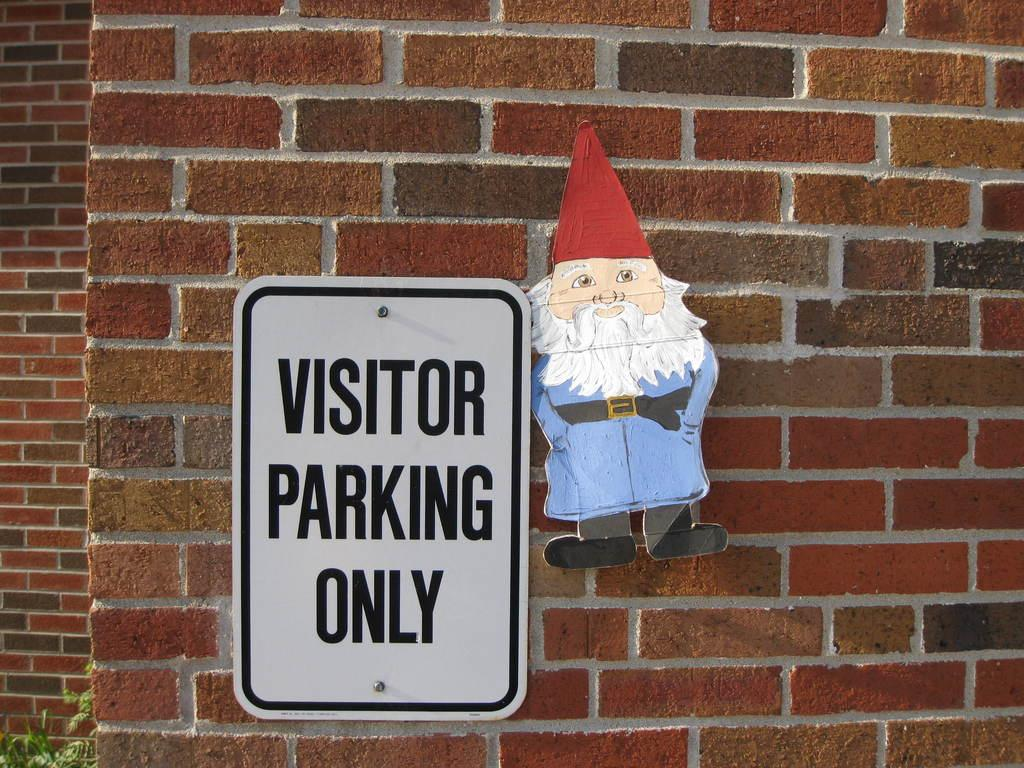What is the main structure visible in the image? There is a wall in the image. What is attached to the wall? There are two boards on the wall. What is depicted on one of the boards? One board contains a picture of a man. What message is conveyed on the other board? The other board has the text "visitor parking only." How many trains are visible in the image? There are no trains present in the image. What type of street is shown in the image? There is no street visible in the image; it features a wall with two boards. 